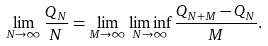<formula> <loc_0><loc_0><loc_500><loc_500>\lim _ { N \to \infty } \frac { Q _ { N } } { N } = \lim _ { M \to \infty } \liminf _ { N \to \infty } \frac { Q _ { N + M } - Q _ { N } } { M } .</formula> 